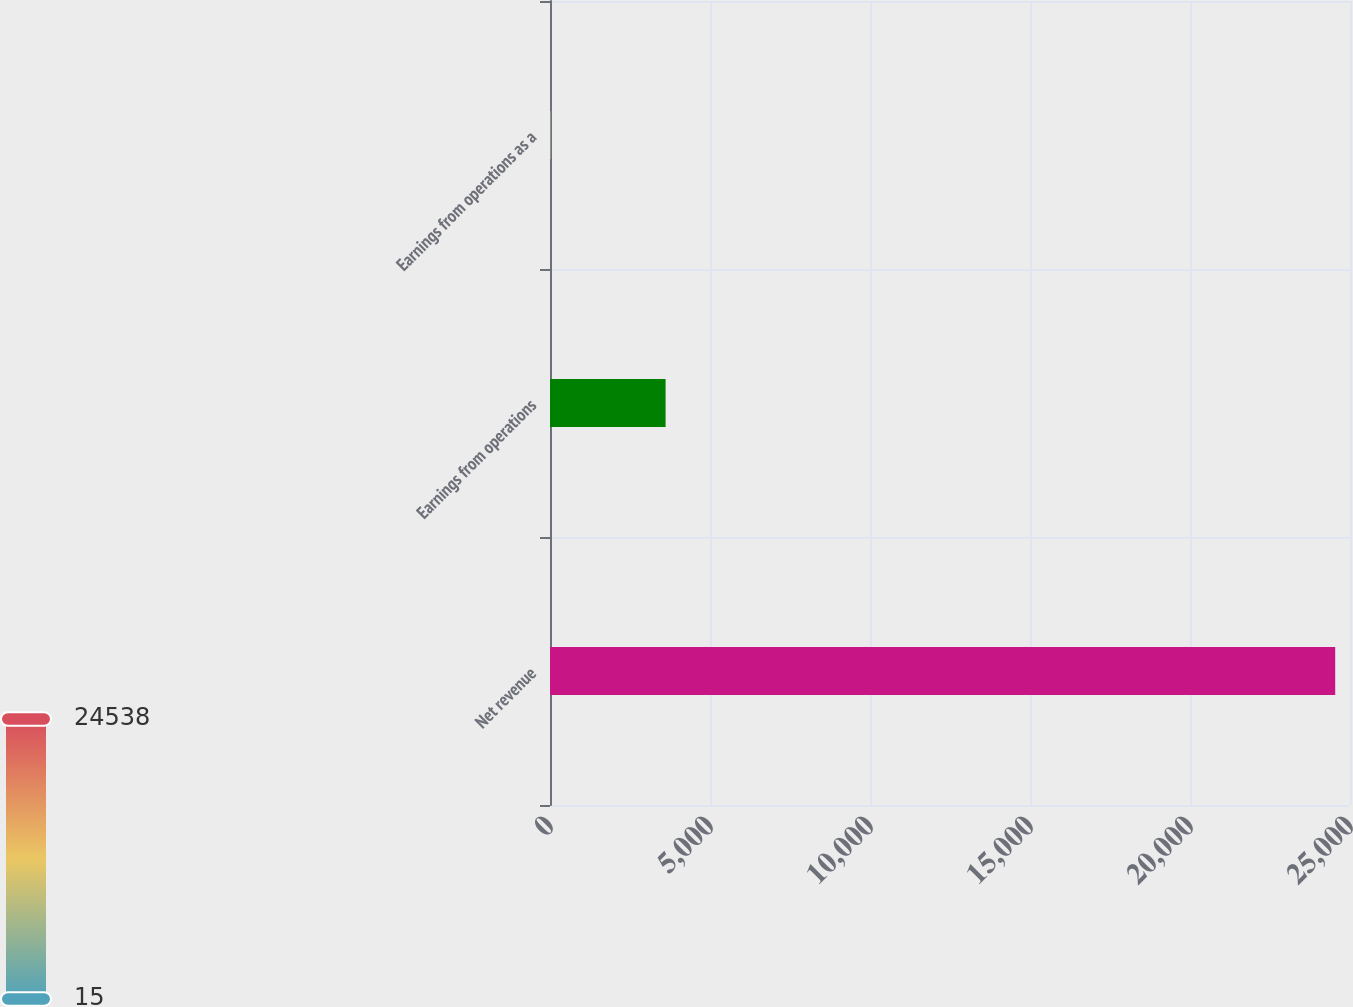Convert chart to OTSL. <chart><loc_0><loc_0><loc_500><loc_500><bar_chart><fcel>Net revenue<fcel>Earnings from operations<fcel>Earnings from operations as a<nl><fcel>24538<fcel>3612<fcel>14.7<nl></chart> 